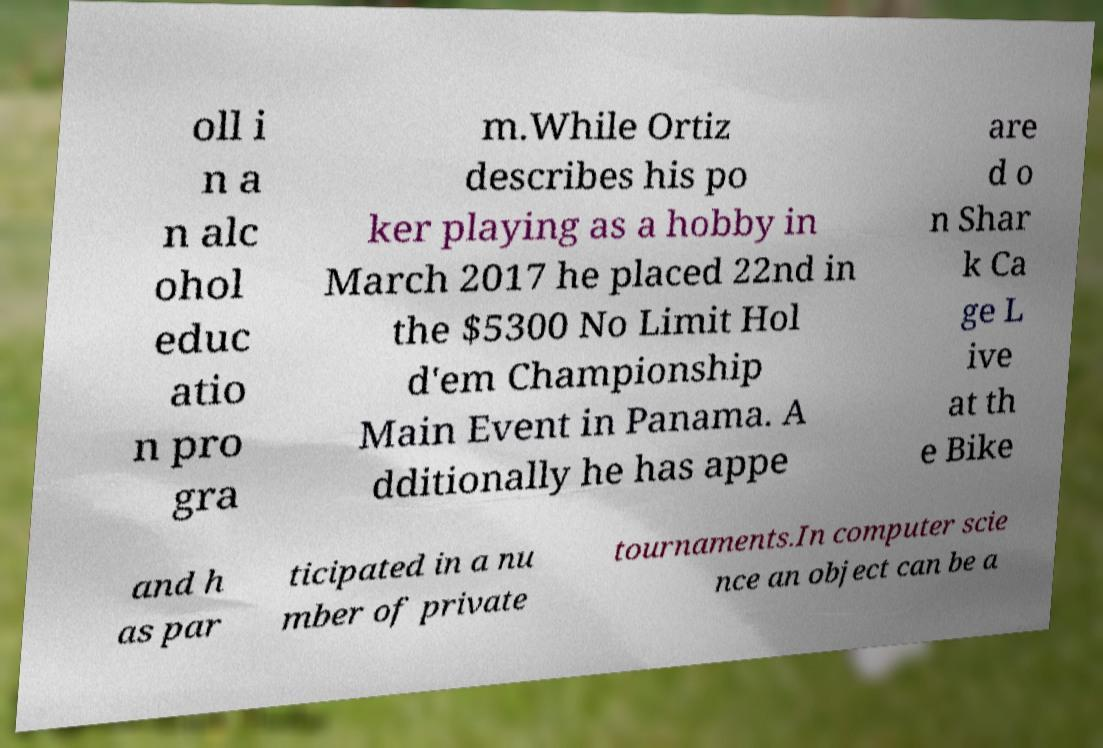I need the written content from this picture converted into text. Can you do that? oll i n a n alc ohol educ atio n pro gra m.While Ortiz describes his po ker playing as a hobby in March 2017 he placed 22nd in the $5300 No Limit Hol d'em Championship Main Event in Panama. A dditionally he has appe are d o n Shar k Ca ge L ive at th e Bike and h as par ticipated in a nu mber of private tournaments.In computer scie nce an object can be a 